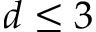Convert formula to latex. <formula><loc_0><loc_0><loc_500><loc_500>d \leq 3</formula> 